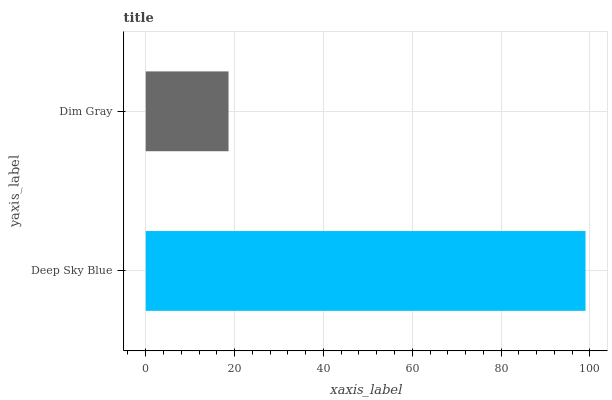Is Dim Gray the minimum?
Answer yes or no. Yes. Is Deep Sky Blue the maximum?
Answer yes or no. Yes. Is Dim Gray the maximum?
Answer yes or no. No. Is Deep Sky Blue greater than Dim Gray?
Answer yes or no. Yes. Is Dim Gray less than Deep Sky Blue?
Answer yes or no. Yes. Is Dim Gray greater than Deep Sky Blue?
Answer yes or no. No. Is Deep Sky Blue less than Dim Gray?
Answer yes or no. No. Is Deep Sky Blue the high median?
Answer yes or no. Yes. Is Dim Gray the low median?
Answer yes or no. Yes. Is Dim Gray the high median?
Answer yes or no. No. Is Deep Sky Blue the low median?
Answer yes or no. No. 